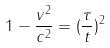Convert formula to latex. <formula><loc_0><loc_0><loc_500><loc_500>1 - \frac { v ^ { 2 } } { c ^ { 2 } } = ( \frac { \tau } { t } ) ^ { 2 }</formula> 